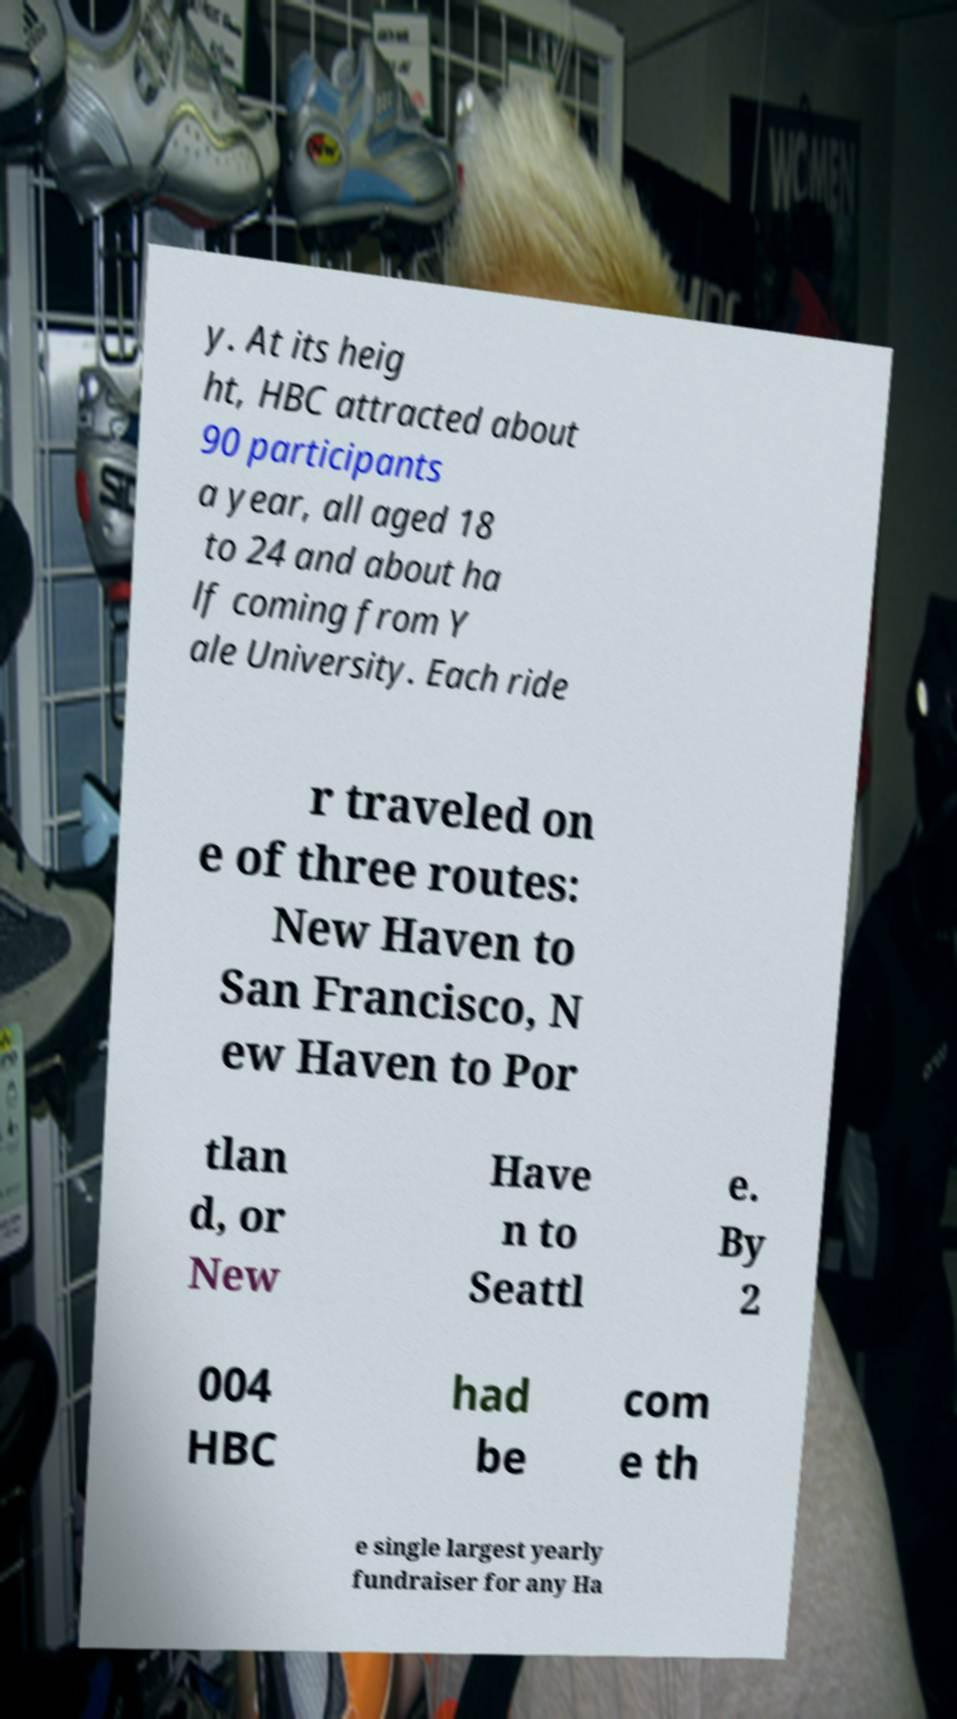Please read and relay the text visible in this image. What does it say? y. At its heig ht, HBC attracted about 90 participants a year, all aged 18 to 24 and about ha lf coming from Y ale University. Each ride r traveled on e of three routes: New Haven to San Francisco, N ew Haven to Por tlan d, or New Have n to Seattl e. By 2 004 HBC had be com e th e single largest yearly fundraiser for any Ha 